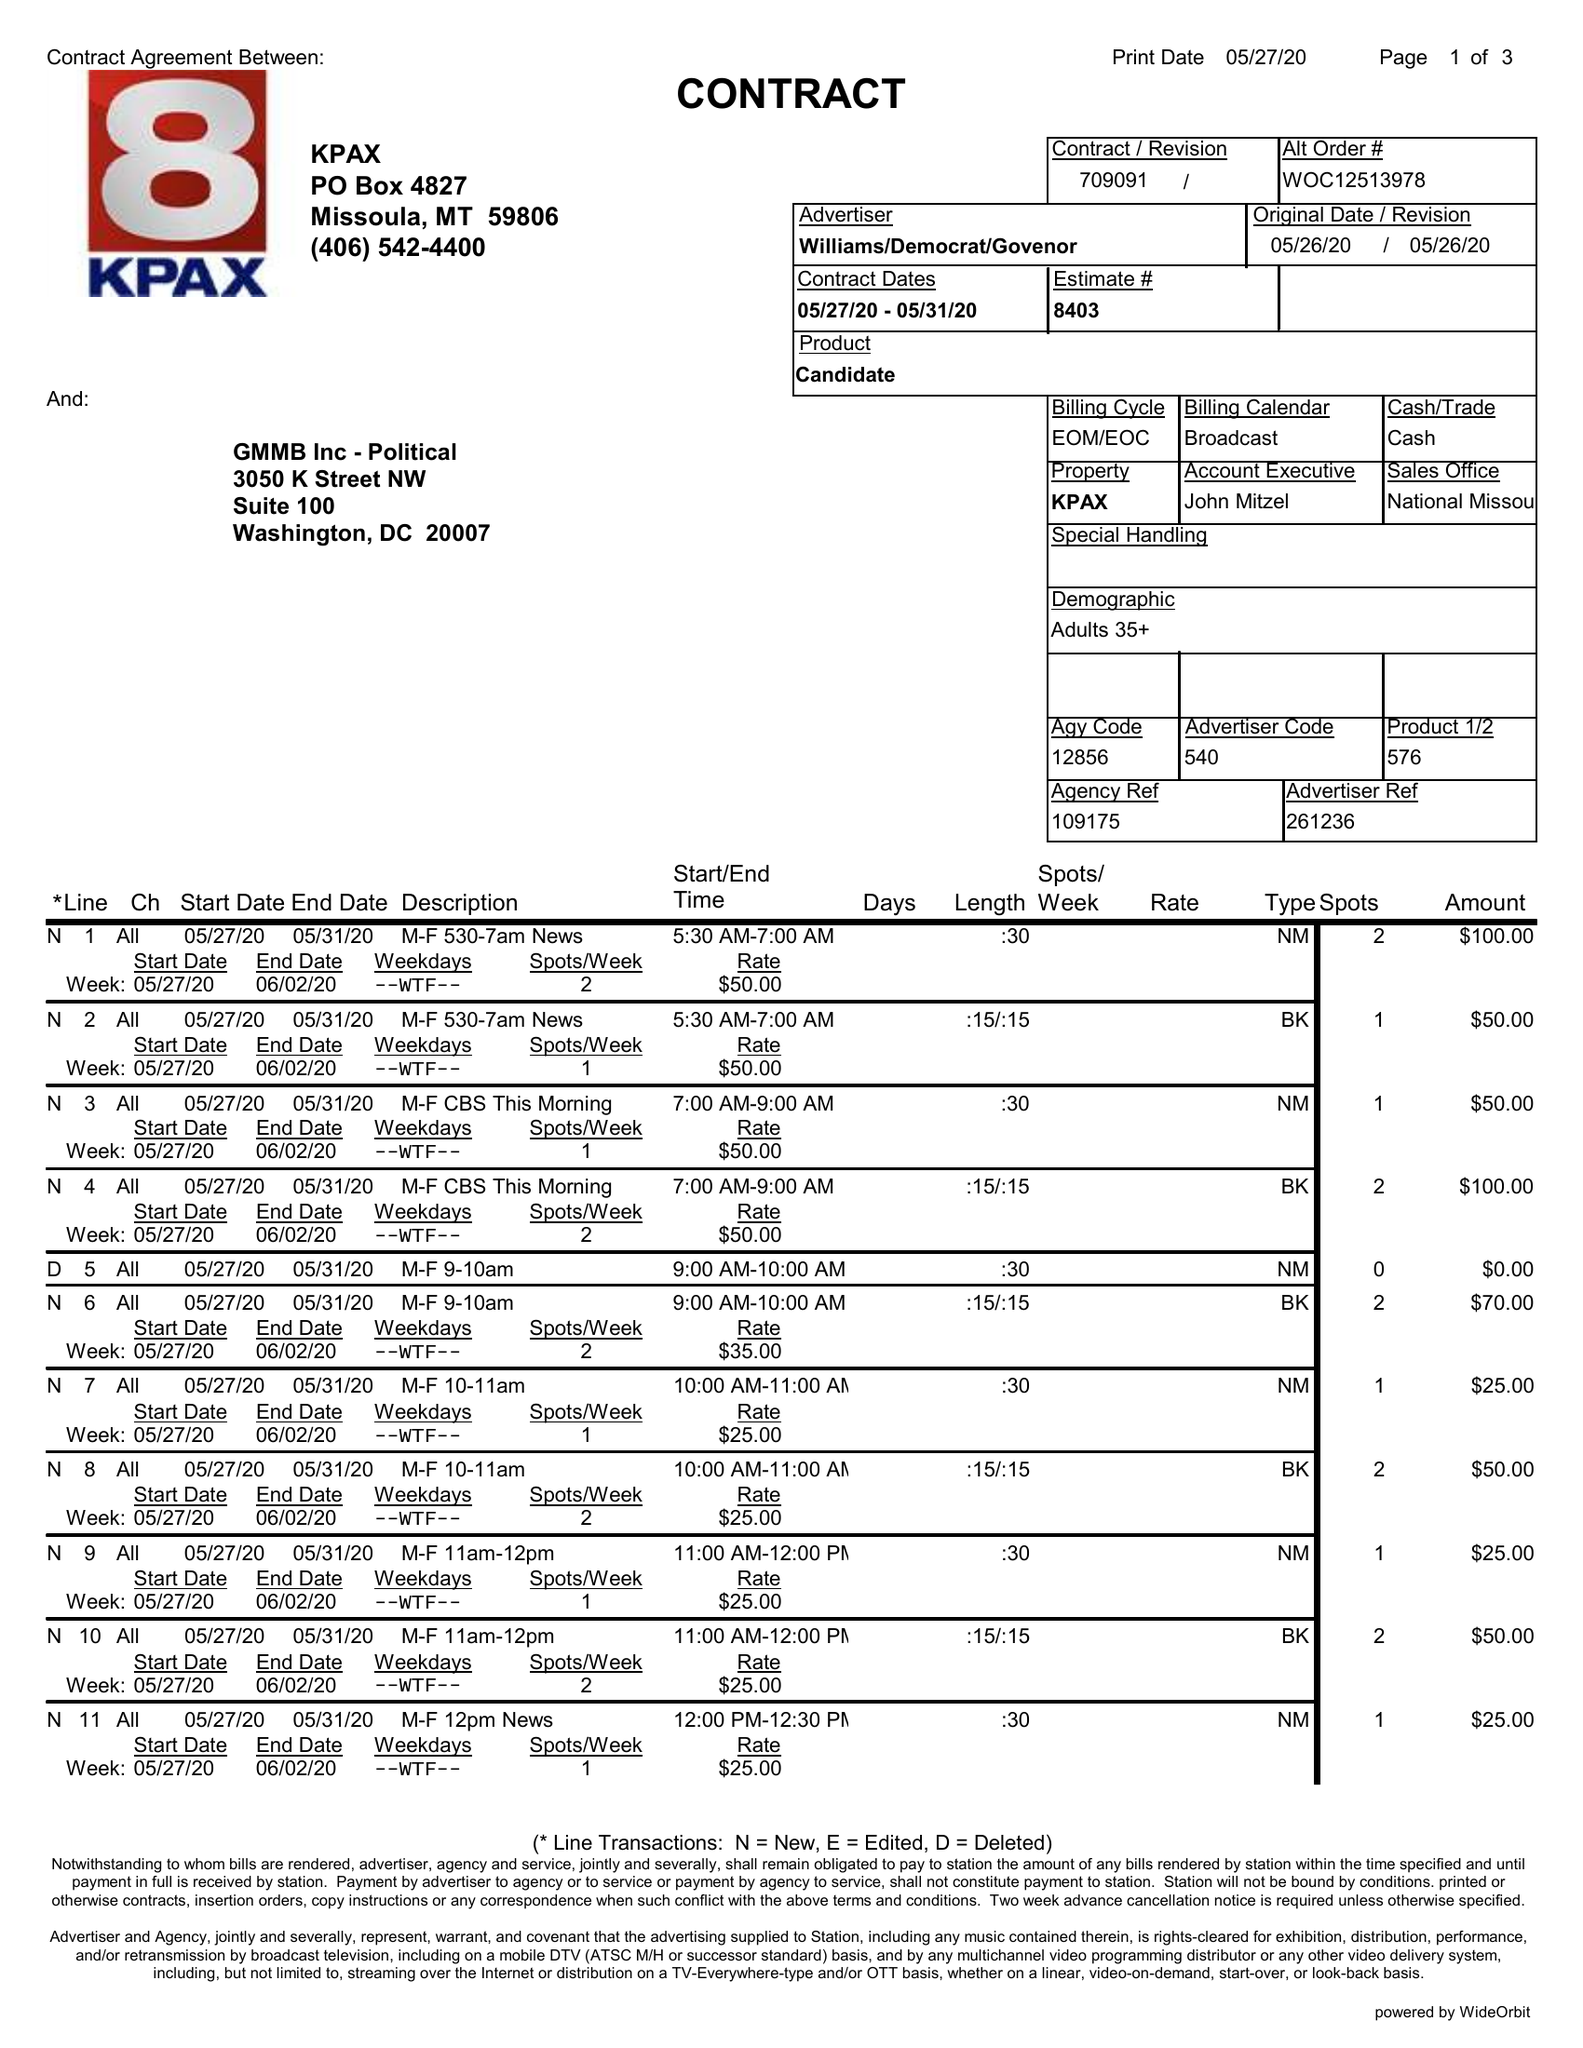What is the value for the gross_amount?
Answer the question using a single word or phrase. 3526.00 